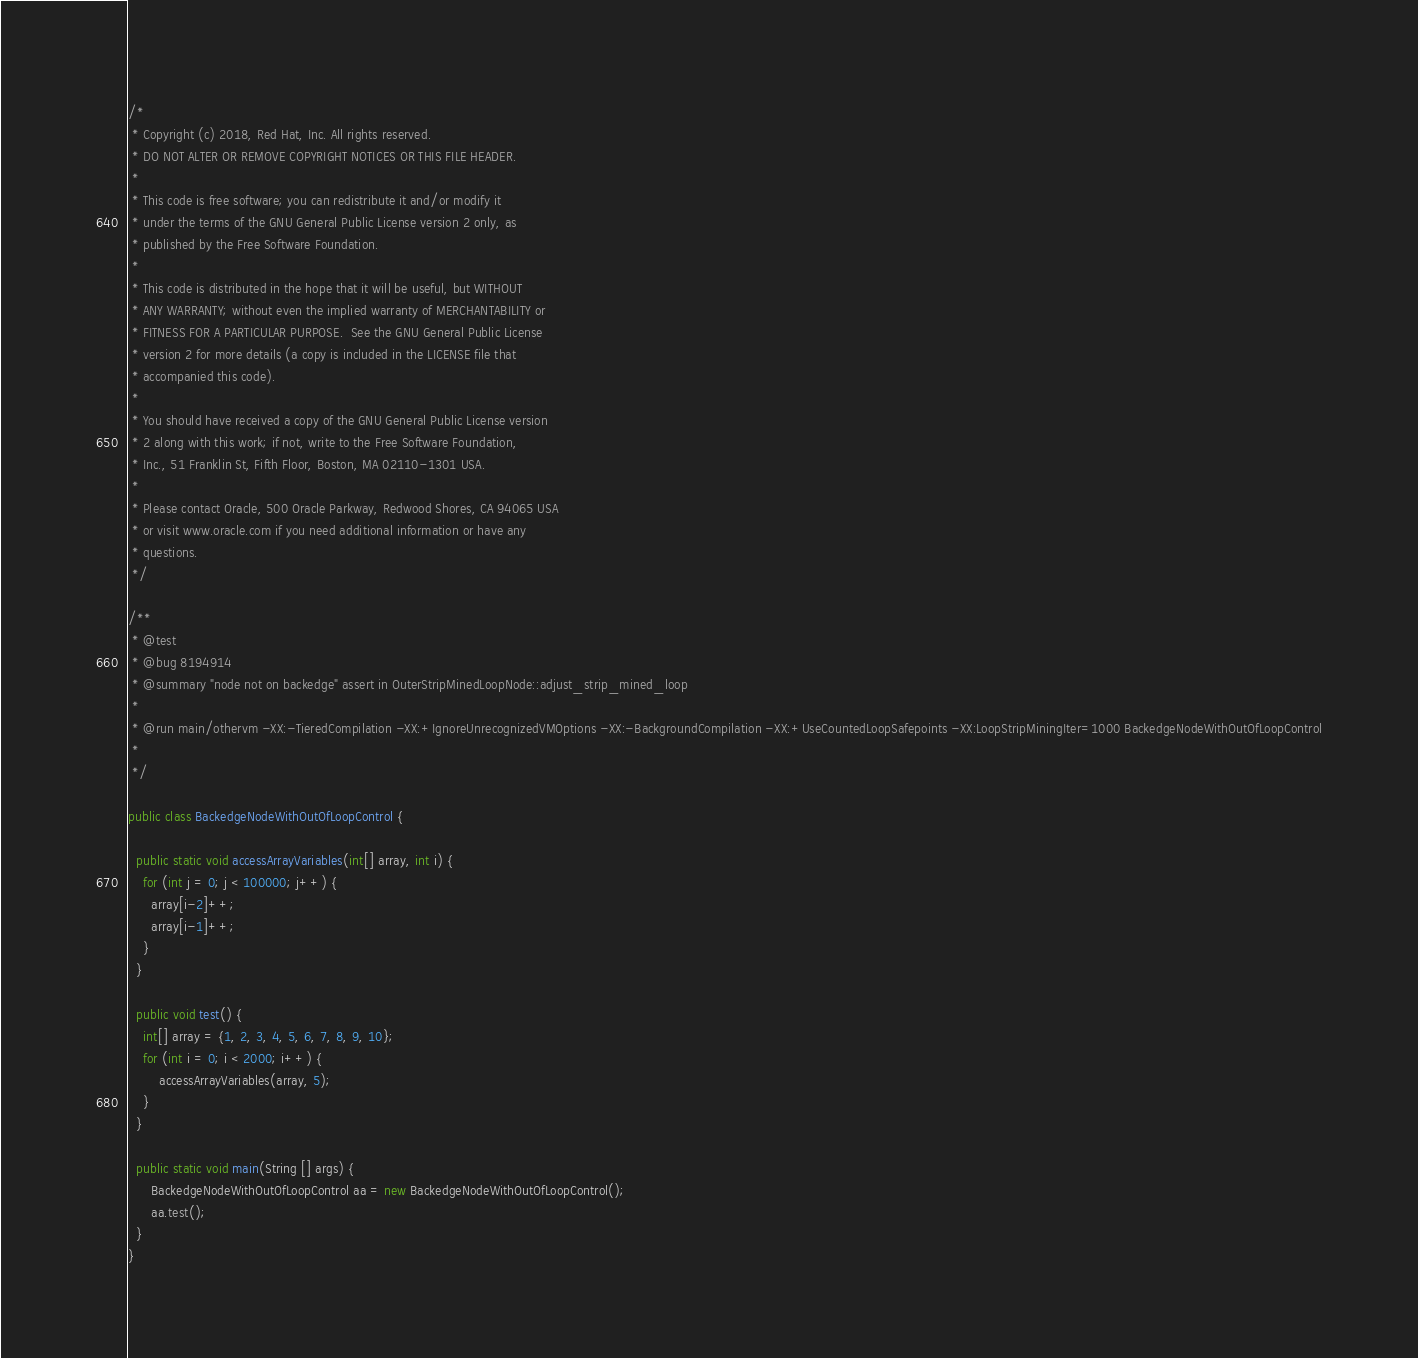<code> <loc_0><loc_0><loc_500><loc_500><_Java_>/*
 * Copyright (c) 2018, Red Hat, Inc. All rights reserved.
 * DO NOT ALTER OR REMOVE COPYRIGHT NOTICES OR THIS FILE HEADER.
 *
 * This code is free software; you can redistribute it and/or modify it
 * under the terms of the GNU General Public License version 2 only, as
 * published by the Free Software Foundation.
 *
 * This code is distributed in the hope that it will be useful, but WITHOUT
 * ANY WARRANTY; without even the implied warranty of MERCHANTABILITY or
 * FITNESS FOR A PARTICULAR PURPOSE.  See the GNU General Public License
 * version 2 for more details (a copy is included in the LICENSE file that
 * accompanied this code).
 *
 * You should have received a copy of the GNU General Public License version
 * 2 along with this work; if not, write to the Free Software Foundation,
 * Inc., 51 Franklin St, Fifth Floor, Boston, MA 02110-1301 USA.
 *
 * Please contact Oracle, 500 Oracle Parkway, Redwood Shores, CA 94065 USA
 * or visit www.oracle.com if you need additional information or have any
 * questions.
 */

/**
 * @test
 * @bug 8194914
 * @summary "node not on backedge" assert in OuterStripMinedLoopNode::adjust_strip_mined_loop
 *
 * @run main/othervm -XX:-TieredCompilation -XX:+IgnoreUnrecognizedVMOptions -XX:-BackgroundCompilation -XX:+UseCountedLoopSafepoints -XX:LoopStripMiningIter=1000 BackedgeNodeWithOutOfLoopControl
 *
 */

public class BackedgeNodeWithOutOfLoopControl {

  public static void accessArrayVariables(int[] array, int i) {
    for (int j = 0; j < 100000; j++) {
      array[i-2]++;
      array[i-1]++;
    }
  }

  public void test() {
    int[] array = {1, 2, 3, 4, 5, 6, 7, 8, 9, 10};
    for (int i = 0; i < 2000; i++) {
        accessArrayVariables(array, 5);
    }
  }

  public static void main(String [] args) {
      BackedgeNodeWithOutOfLoopControl aa = new BackedgeNodeWithOutOfLoopControl();
      aa.test();
  }
}
</code> 